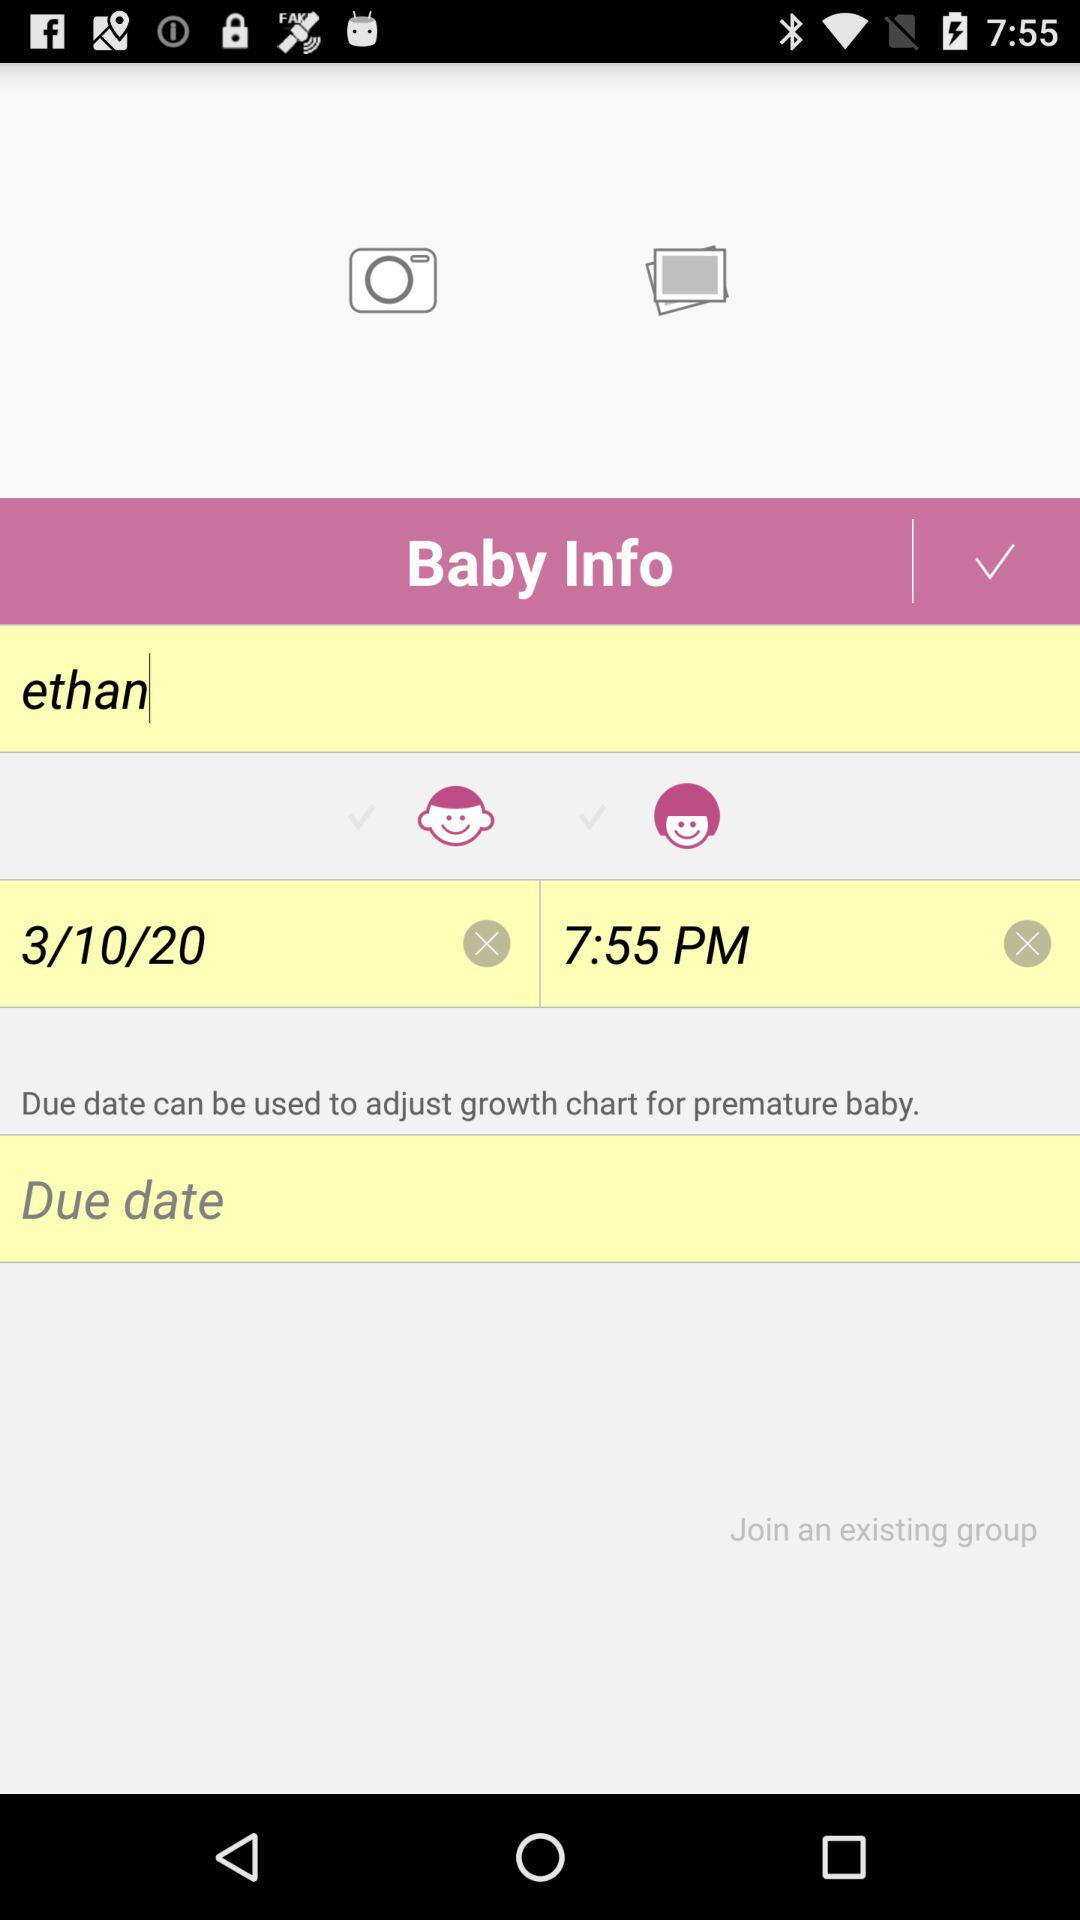What is the baby name? The baby name is Ethan. 